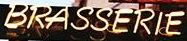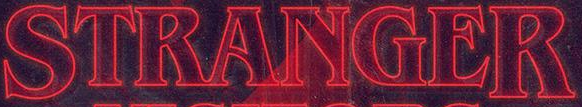Identify the words shown in these images in order, separated by a semicolon. BRASSERIE; STRANGER 